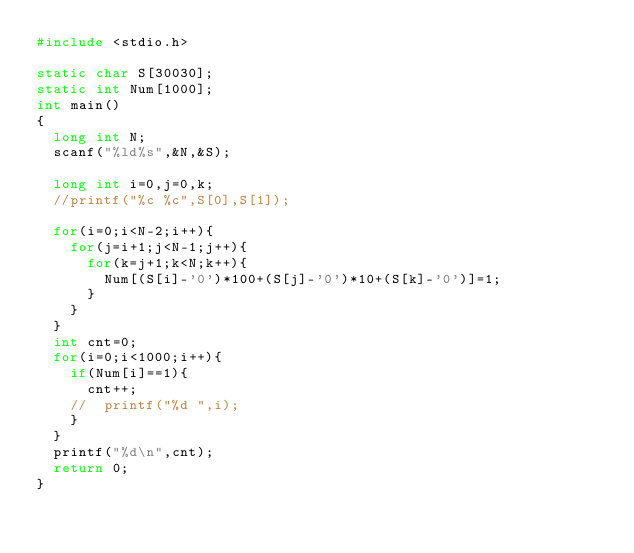Convert code to text. <code><loc_0><loc_0><loc_500><loc_500><_C_>#include <stdio.h>

static char S[30030];
static int Num[1000];
int main()
{
	long int N;
	scanf("%ld%s",&N,&S);

	long int i=0,j=0,k;
	//printf("%c %c",S[0],S[1]);
	
	for(i=0;i<N-2;i++){
		for(j=i+1;j<N-1;j++){
			for(k=j+1;k<N;k++){
				Num[(S[i]-'0')*100+(S[j]-'0')*10+(S[k]-'0')]=1;
			}
		}
	}
	int cnt=0;
	for(i=0;i<1000;i++){
		if(Num[i]==1){
			cnt++;
		//	printf("%d ",i);
		}
	}
	printf("%d\n",cnt);
	return 0;
}</code> 